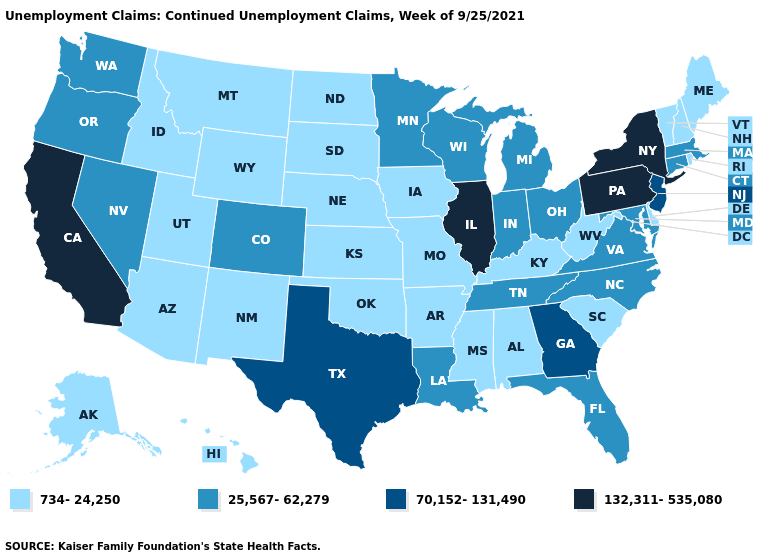Which states have the lowest value in the USA?
Be succinct. Alabama, Alaska, Arizona, Arkansas, Delaware, Hawaii, Idaho, Iowa, Kansas, Kentucky, Maine, Mississippi, Missouri, Montana, Nebraska, New Hampshire, New Mexico, North Dakota, Oklahoma, Rhode Island, South Carolina, South Dakota, Utah, Vermont, West Virginia, Wyoming. Among the states that border Idaho , does Montana have the lowest value?
Keep it brief. Yes. What is the lowest value in the USA?
Give a very brief answer. 734-24,250. Name the states that have a value in the range 25,567-62,279?
Be succinct. Colorado, Connecticut, Florida, Indiana, Louisiana, Maryland, Massachusetts, Michigan, Minnesota, Nevada, North Carolina, Ohio, Oregon, Tennessee, Virginia, Washington, Wisconsin. What is the lowest value in the USA?
Quick response, please. 734-24,250. What is the value of Maryland?
Short answer required. 25,567-62,279. Which states have the lowest value in the USA?
Concise answer only. Alabama, Alaska, Arizona, Arkansas, Delaware, Hawaii, Idaho, Iowa, Kansas, Kentucky, Maine, Mississippi, Missouri, Montana, Nebraska, New Hampshire, New Mexico, North Dakota, Oklahoma, Rhode Island, South Carolina, South Dakota, Utah, Vermont, West Virginia, Wyoming. Which states hav the highest value in the South?
Concise answer only. Georgia, Texas. What is the value of New Hampshire?
Quick response, please. 734-24,250. Name the states that have a value in the range 132,311-535,080?
Give a very brief answer. California, Illinois, New York, Pennsylvania. Is the legend a continuous bar?
Short answer required. No. What is the value of Texas?
Concise answer only. 70,152-131,490. What is the highest value in the USA?
Write a very short answer. 132,311-535,080. Which states have the lowest value in the USA?
Concise answer only. Alabama, Alaska, Arizona, Arkansas, Delaware, Hawaii, Idaho, Iowa, Kansas, Kentucky, Maine, Mississippi, Missouri, Montana, Nebraska, New Hampshire, New Mexico, North Dakota, Oklahoma, Rhode Island, South Carolina, South Dakota, Utah, Vermont, West Virginia, Wyoming. What is the highest value in the USA?
Keep it brief. 132,311-535,080. 